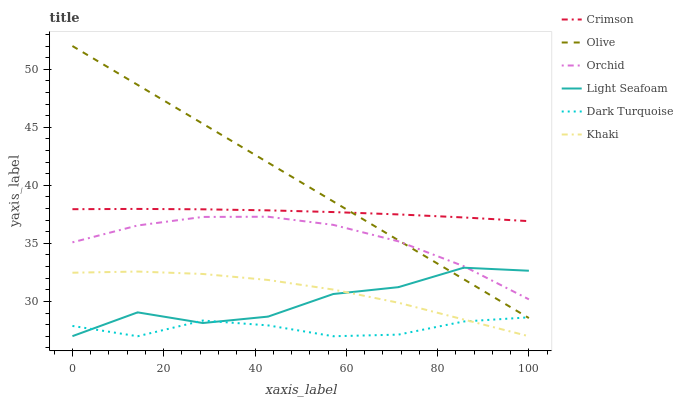Does Olive have the minimum area under the curve?
Answer yes or no. No. Does Dark Turquoise have the maximum area under the curve?
Answer yes or no. No. Is Dark Turquoise the smoothest?
Answer yes or no. No. Is Dark Turquoise the roughest?
Answer yes or no. No. Does Olive have the lowest value?
Answer yes or no. No. Does Dark Turquoise have the highest value?
Answer yes or no. No. Is Khaki less than Orchid?
Answer yes or no. Yes. Is Crimson greater than Dark Turquoise?
Answer yes or no. Yes. Does Khaki intersect Orchid?
Answer yes or no. No. 